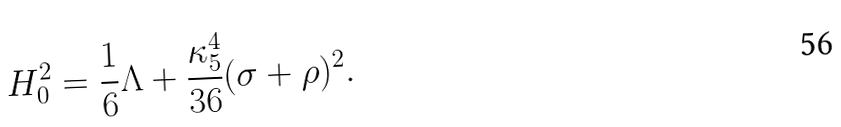<formula> <loc_0><loc_0><loc_500><loc_500>H _ { 0 } ^ { 2 } = \frac { 1 } { 6 } \Lambda + \frac { \kappa _ { 5 } ^ { 4 } } { 3 6 } ( \sigma + \rho ) ^ { 2 } .</formula> 